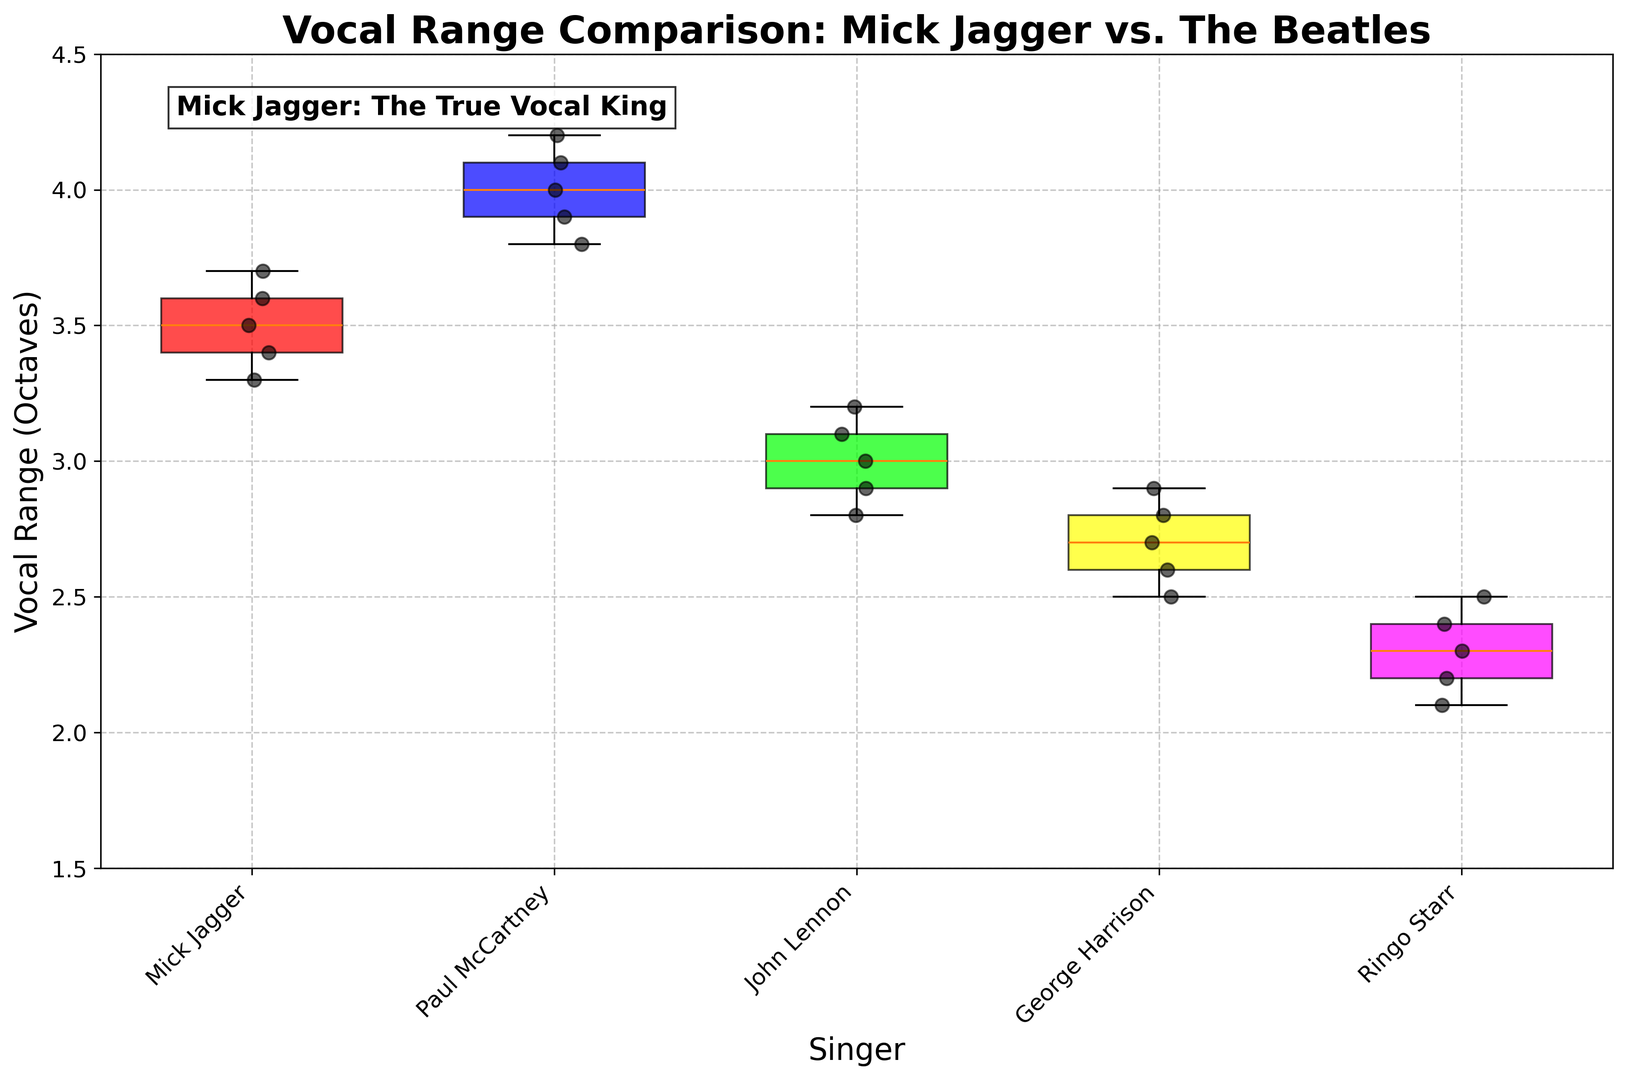What is the median vocal range for Mick Jagger? To find the median vocal range for Mick Jagger, we need to order his vocal range values and find the middle number. Mick Jagger's vocal range values are 3.3, 3.4, 3.5, 3.6, and 3.7. The middle value is 3.5.
Answer: 3.5 How does the median vocal range of Paul McCartney compare to Mick Jagger's median? Paul McCartney's vocal range values are 3.8, 3.9, 4.0, 4.1, and 4.2. The median is 4.0. Mick Jagger's median is 3.5. Comparing the two medians, 4.0 is greater than 3.5.
Answer: Paul McCartney's median is higher Which singer has the widest vocal range according to the box plot? The widest vocal range can be identified by looking at the length of the box and whiskers in the box plot. Paul McCartney has the widest range as his vocal range spans from 3.8 to 4.2 octaves.
Answer: Paul McCartney What is the interquartile range (IQR) of Ringo Starr's vocal range? The interquartile range (IQR) is the difference between the third quartile (Q3) and the first quartile (Q1). For Ringo Starr, Q1 is 2.2 and Q3 is 2.4. Therefore, IQR = 2.4 - 2.2 = 0.2.
Answer: 0.2 Who has the smallest median vocal range and what is it? To find the smallest median, we compare the middle values of each singer's vocal range. Mick Jagger's median is 3.5, Paul McCartney's is 4.0, John Lennon's is 3.0, George Harrison's is 2.7, and Ringo Starr's is 2.4. The smallest median vocal range is 2.4, belonging to Ringo Starr.
Answer: Ringo Starr, 2.4 Which singers' vocal ranges overlap in the box plot? Overlapping ranges can be seen where the boxes or whiskers intersect. Mick Jagger's range (3.3 to 3.7) overlaps with the lower end of Paul McCartney's range (3.8 to 4.2). John Lennon's range (2.8 to 3.2) overlaps with George Harrison's range (2.5 to 2.9).
Answer: Mick Jagger and Paul McCartney; John Lennon and George Harrison What color is the box representing John Lennon's vocal range? The color of the boxes can be identified visually from the plot. John Lennon's box is green in color.
Answer: Green How does the highest value of Mick Jagger's vocal range compare to the lowest value of Paul McCartney's? Mick Jagger's highest value is 3.7 and Paul McCartney's lowest value is 3.8. Comparing these values, 3.8 is greater than 3.7.
Answer: Paul McCartney's lowest value is higher What is the range of George Harrison's vocal range? The range is calculated by subtracting the smallest value from the largest value. For George Harrison, the values range from 2.5 to 2.9. Thus, the range is 2.9 - 2.5 = 0.4 octaves.
Answer: 0.4 